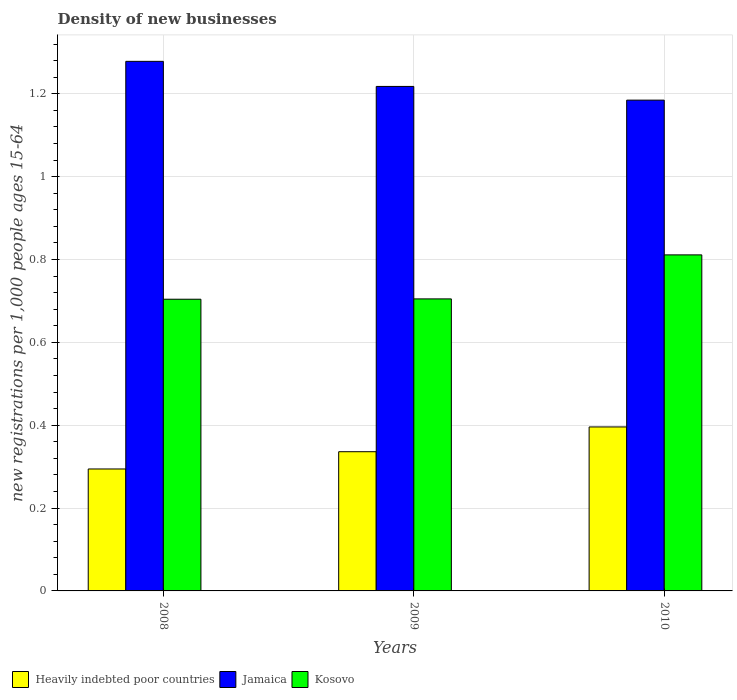How many groups of bars are there?
Your response must be concise. 3. Are the number of bars per tick equal to the number of legend labels?
Your response must be concise. Yes. Are the number of bars on each tick of the X-axis equal?
Your answer should be very brief. Yes. How many bars are there on the 3rd tick from the left?
Keep it short and to the point. 3. How many bars are there on the 3rd tick from the right?
Provide a succinct answer. 3. What is the number of new registrations in Heavily indebted poor countries in 2009?
Offer a very short reply. 0.34. Across all years, what is the maximum number of new registrations in Heavily indebted poor countries?
Your response must be concise. 0.4. Across all years, what is the minimum number of new registrations in Kosovo?
Give a very brief answer. 0.7. In which year was the number of new registrations in Jamaica minimum?
Ensure brevity in your answer.  2010. What is the total number of new registrations in Kosovo in the graph?
Provide a succinct answer. 2.22. What is the difference between the number of new registrations in Heavily indebted poor countries in 2009 and that in 2010?
Provide a succinct answer. -0.06. What is the difference between the number of new registrations in Kosovo in 2010 and the number of new registrations in Heavily indebted poor countries in 2009?
Make the answer very short. 0.48. What is the average number of new registrations in Heavily indebted poor countries per year?
Offer a terse response. 0.34. In the year 2010, what is the difference between the number of new registrations in Kosovo and number of new registrations in Heavily indebted poor countries?
Keep it short and to the point. 0.42. In how many years, is the number of new registrations in Heavily indebted poor countries greater than 0.56?
Provide a succinct answer. 0. What is the ratio of the number of new registrations in Kosovo in 2009 to that in 2010?
Your answer should be compact. 0.87. Is the difference between the number of new registrations in Kosovo in 2009 and 2010 greater than the difference between the number of new registrations in Heavily indebted poor countries in 2009 and 2010?
Offer a terse response. No. What is the difference between the highest and the second highest number of new registrations in Heavily indebted poor countries?
Your response must be concise. 0.06. What is the difference between the highest and the lowest number of new registrations in Heavily indebted poor countries?
Make the answer very short. 0.1. What does the 1st bar from the left in 2010 represents?
Your response must be concise. Heavily indebted poor countries. What does the 3rd bar from the right in 2010 represents?
Offer a very short reply. Heavily indebted poor countries. How many bars are there?
Provide a succinct answer. 9. Are all the bars in the graph horizontal?
Provide a short and direct response. No. How many years are there in the graph?
Provide a short and direct response. 3. What is the difference between two consecutive major ticks on the Y-axis?
Offer a very short reply. 0.2. Are the values on the major ticks of Y-axis written in scientific E-notation?
Provide a succinct answer. No. Does the graph contain any zero values?
Ensure brevity in your answer.  No. Where does the legend appear in the graph?
Make the answer very short. Bottom left. How many legend labels are there?
Give a very brief answer. 3. How are the legend labels stacked?
Your response must be concise. Horizontal. What is the title of the graph?
Offer a terse response. Density of new businesses. Does "Belarus" appear as one of the legend labels in the graph?
Offer a terse response. No. What is the label or title of the X-axis?
Your answer should be compact. Years. What is the label or title of the Y-axis?
Offer a terse response. New registrations per 1,0 people ages 15-64. What is the new registrations per 1,000 people ages 15-64 of Heavily indebted poor countries in 2008?
Offer a very short reply. 0.29. What is the new registrations per 1,000 people ages 15-64 of Jamaica in 2008?
Offer a terse response. 1.28. What is the new registrations per 1,000 people ages 15-64 of Kosovo in 2008?
Your response must be concise. 0.7. What is the new registrations per 1,000 people ages 15-64 of Heavily indebted poor countries in 2009?
Make the answer very short. 0.34. What is the new registrations per 1,000 people ages 15-64 in Jamaica in 2009?
Make the answer very short. 1.22. What is the new registrations per 1,000 people ages 15-64 in Kosovo in 2009?
Give a very brief answer. 0.7. What is the new registrations per 1,000 people ages 15-64 of Heavily indebted poor countries in 2010?
Keep it short and to the point. 0.4. What is the new registrations per 1,000 people ages 15-64 in Jamaica in 2010?
Your answer should be very brief. 1.18. What is the new registrations per 1,000 people ages 15-64 in Kosovo in 2010?
Keep it short and to the point. 0.81. Across all years, what is the maximum new registrations per 1,000 people ages 15-64 in Heavily indebted poor countries?
Your answer should be very brief. 0.4. Across all years, what is the maximum new registrations per 1,000 people ages 15-64 in Jamaica?
Your answer should be very brief. 1.28. Across all years, what is the maximum new registrations per 1,000 people ages 15-64 in Kosovo?
Offer a terse response. 0.81. Across all years, what is the minimum new registrations per 1,000 people ages 15-64 in Heavily indebted poor countries?
Your answer should be compact. 0.29. Across all years, what is the minimum new registrations per 1,000 people ages 15-64 in Jamaica?
Your answer should be compact. 1.18. Across all years, what is the minimum new registrations per 1,000 people ages 15-64 in Kosovo?
Your response must be concise. 0.7. What is the total new registrations per 1,000 people ages 15-64 of Heavily indebted poor countries in the graph?
Offer a terse response. 1.03. What is the total new registrations per 1,000 people ages 15-64 in Jamaica in the graph?
Keep it short and to the point. 3.68. What is the total new registrations per 1,000 people ages 15-64 in Kosovo in the graph?
Offer a terse response. 2.22. What is the difference between the new registrations per 1,000 people ages 15-64 in Heavily indebted poor countries in 2008 and that in 2009?
Your answer should be compact. -0.04. What is the difference between the new registrations per 1,000 people ages 15-64 in Jamaica in 2008 and that in 2009?
Give a very brief answer. 0.06. What is the difference between the new registrations per 1,000 people ages 15-64 in Kosovo in 2008 and that in 2009?
Ensure brevity in your answer.  -0. What is the difference between the new registrations per 1,000 people ages 15-64 of Heavily indebted poor countries in 2008 and that in 2010?
Give a very brief answer. -0.1. What is the difference between the new registrations per 1,000 people ages 15-64 in Jamaica in 2008 and that in 2010?
Offer a very short reply. 0.09. What is the difference between the new registrations per 1,000 people ages 15-64 of Kosovo in 2008 and that in 2010?
Make the answer very short. -0.11. What is the difference between the new registrations per 1,000 people ages 15-64 in Heavily indebted poor countries in 2009 and that in 2010?
Ensure brevity in your answer.  -0.06. What is the difference between the new registrations per 1,000 people ages 15-64 of Jamaica in 2009 and that in 2010?
Provide a short and direct response. 0.03. What is the difference between the new registrations per 1,000 people ages 15-64 in Kosovo in 2009 and that in 2010?
Offer a terse response. -0.11. What is the difference between the new registrations per 1,000 people ages 15-64 of Heavily indebted poor countries in 2008 and the new registrations per 1,000 people ages 15-64 of Jamaica in 2009?
Give a very brief answer. -0.92. What is the difference between the new registrations per 1,000 people ages 15-64 in Heavily indebted poor countries in 2008 and the new registrations per 1,000 people ages 15-64 in Kosovo in 2009?
Your answer should be very brief. -0.41. What is the difference between the new registrations per 1,000 people ages 15-64 in Jamaica in 2008 and the new registrations per 1,000 people ages 15-64 in Kosovo in 2009?
Offer a very short reply. 0.57. What is the difference between the new registrations per 1,000 people ages 15-64 in Heavily indebted poor countries in 2008 and the new registrations per 1,000 people ages 15-64 in Jamaica in 2010?
Provide a succinct answer. -0.89. What is the difference between the new registrations per 1,000 people ages 15-64 of Heavily indebted poor countries in 2008 and the new registrations per 1,000 people ages 15-64 of Kosovo in 2010?
Give a very brief answer. -0.52. What is the difference between the new registrations per 1,000 people ages 15-64 of Jamaica in 2008 and the new registrations per 1,000 people ages 15-64 of Kosovo in 2010?
Your answer should be compact. 0.47. What is the difference between the new registrations per 1,000 people ages 15-64 of Heavily indebted poor countries in 2009 and the new registrations per 1,000 people ages 15-64 of Jamaica in 2010?
Offer a very short reply. -0.85. What is the difference between the new registrations per 1,000 people ages 15-64 in Heavily indebted poor countries in 2009 and the new registrations per 1,000 people ages 15-64 in Kosovo in 2010?
Provide a short and direct response. -0.48. What is the difference between the new registrations per 1,000 people ages 15-64 of Jamaica in 2009 and the new registrations per 1,000 people ages 15-64 of Kosovo in 2010?
Your answer should be compact. 0.41. What is the average new registrations per 1,000 people ages 15-64 of Heavily indebted poor countries per year?
Your answer should be compact. 0.34. What is the average new registrations per 1,000 people ages 15-64 of Jamaica per year?
Keep it short and to the point. 1.23. What is the average new registrations per 1,000 people ages 15-64 in Kosovo per year?
Provide a succinct answer. 0.74. In the year 2008, what is the difference between the new registrations per 1,000 people ages 15-64 of Heavily indebted poor countries and new registrations per 1,000 people ages 15-64 of Jamaica?
Your answer should be very brief. -0.98. In the year 2008, what is the difference between the new registrations per 1,000 people ages 15-64 in Heavily indebted poor countries and new registrations per 1,000 people ages 15-64 in Kosovo?
Give a very brief answer. -0.41. In the year 2008, what is the difference between the new registrations per 1,000 people ages 15-64 in Jamaica and new registrations per 1,000 people ages 15-64 in Kosovo?
Provide a succinct answer. 0.57. In the year 2009, what is the difference between the new registrations per 1,000 people ages 15-64 in Heavily indebted poor countries and new registrations per 1,000 people ages 15-64 in Jamaica?
Your answer should be compact. -0.88. In the year 2009, what is the difference between the new registrations per 1,000 people ages 15-64 in Heavily indebted poor countries and new registrations per 1,000 people ages 15-64 in Kosovo?
Provide a short and direct response. -0.37. In the year 2009, what is the difference between the new registrations per 1,000 people ages 15-64 of Jamaica and new registrations per 1,000 people ages 15-64 of Kosovo?
Your response must be concise. 0.51. In the year 2010, what is the difference between the new registrations per 1,000 people ages 15-64 of Heavily indebted poor countries and new registrations per 1,000 people ages 15-64 of Jamaica?
Your response must be concise. -0.79. In the year 2010, what is the difference between the new registrations per 1,000 people ages 15-64 of Heavily indebted poor countries and new registrations per 1,000 people ages 15-64 of Kosovo?
Provide a succinct answer. -0.42. In the year 2010, what is the difference between the new registrations per 1,000 people ages 15-64 in Jamaica and new registrations per 1,000 people ages 15-64 in Kosovo?
Give a very brief answer. 0.37. What is the ratio of the new registrations per 1,000 people ages 15-64 of Heavily indebted poor countries in 2008 to that in 2009?
Ensure brevity in your answer.  0.88. What is the ratio of the new registrations per 1,000 people ages 15-64 of Jamaica in 2008 to that in 2009?
Provide a succinct answer. 1.05. What is the ratio of the new registrations per 1,000 people ages 15-64 in Heavily indebted poor countries in 2008 to that in 2010?
Provide a short and direct response. 0.74. What is the ratio of the new registrations per 1,000 people ages 15-64 of Jamaica in 2008 to that in 2010?
Offer a very short reply. 1.08. What is the ratio of the new registrations per 1,000 people ages 15-64 of Kosovo in 2008 to that in 2010?
Ensure brevity in your answer.  0.87. What is the ratio of the new registrations per 1,000 people ages 15-64 in Heavily indebted poor countries in 2009 to that in 2010?
Provide a short and direct response. 0.85. What is the ratio of the new registrations per 1,000 people ages 15-64 in Jamaica in 2009 to that in 2010?
Provide a short and direct response. 1.03. What is the ratio of the new registrations per 1,000 people ages 15-64 of Kosovo in 2009 to that in 2010?
Your answer should be very brief. 0.87. What is the difference between the highest and the second highest new registrations per 1,000 people ages 15-64 in Heavily indebted poor countries?
Ensure brevity in your answer.  0.06. What is the difference between the highest and the second highest new registrations per 1,000 people ages 15-64 in Jamaica?
Provide a short and direct response. 0.06. What is the difference between the highest and the second highest new registrations per 1,000 people ages 15-64 of Kosovo?
Provide a succinct answer. 0.11. What is the difference between the highest and the lowest new registrations per 1,000 people ages 15-64 of Heavily indebted poor countries?
Your answer should be very brief. 0.1. What is the difference between the highest and the lowest new registrations per 1,000 people ages 15-64 of Jamaica?
Your answer should be very brief. 0.09. What is the difference between the highest and the lowest new registrations per 1,000 people ages 15-64 of Kosovo?
Offer a very short reply. 0.11. 